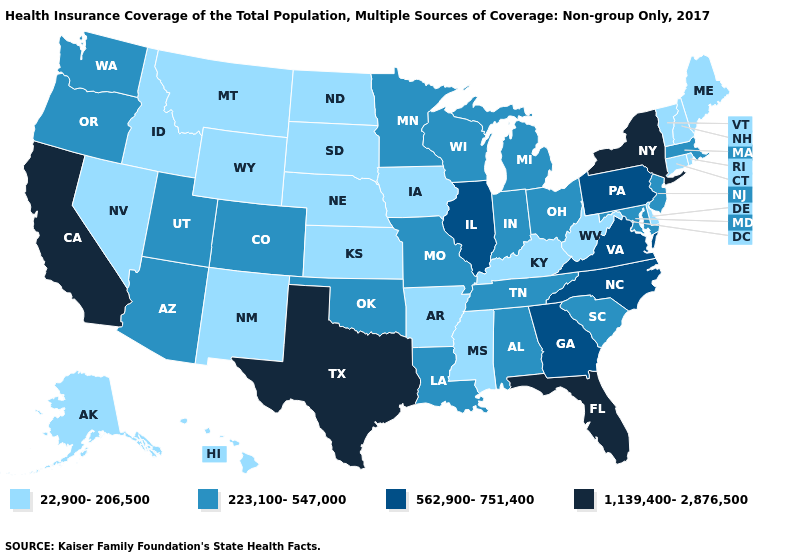Name the states that have a value in the range 223,100-547,000?
Short answer required. Alabama, Arizona, Colorado, Indiana, Louisiana, Maryland, Massachusetts, Michigan, Minnesota, Missouri, New Jersey, Ohio, Oklahoma, Oregon, South Carolina, Tennessee, Utah, Washington, Wisconsin. What is the lowest value in the USA?
Quick response, please. 22,900-206,500. Among the states that border New York , which have the lowest value?
Give a very brief answer. Connecticut, Vermont. Which states have the lowest value in the USA?
Quick response, please. Alaska, Arkansas, Connecticut, Delaware, Hawaii, Idaho, Iowa, Kansas, Kentucky, Maine, Mississippi, Montana, Nebraska, Nevada, New Hampshire, New Mexico, North Dakota, Rhode Island, South Dakota, Vermont, West Virginia, Wyoming. Among the states that border North Carolina , which have the highest value?
Keep it brief. Georgia, Virginia. Which states have the highest value in the USA?
Short answer required. California, Florida, New York, Texas. Does Texas have the highest value in the USA?
Short answer required. Yes. What is the value of Michigan?
Short answer required. 223,100-547,000. Which states hav the highest value in the South?
Write a very short answer. Florida, Texas. What is the value of Nevada?
Quick response, please. 22,900-206,500. What is the highest value in the USA?
Keep it brief. 1,139,400-2,876,500. Which states have the lowest value in the West?
Write a very short answer. Alaska, Hawaii, Idaho, Montana, Nevada, New Mexico, Wyoming. Does New York have a higher value than Minnesota?
Quick response, please. Yes. Does the map have missing data?
Be succinct. No. Which states have the highest value in the USA?
Quick response, please. California, Florida, New York, Texas. 